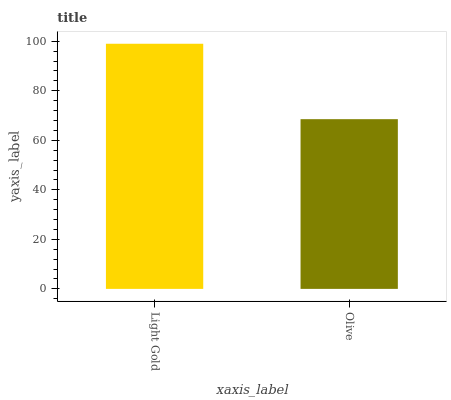Is Olive the minimum?
Answer yes or no. Yes. Is Light Gold the maximum?
Answer yes or no. Yes. Is Olive the maximum?
Answer yes or no. No. Is Light Gold greater than Olive?
Answer yes or no. Yes. Is Olive less than Light Gold?
Answer yes or no. Yes. Is Olive greater than Light Gold?
Answer yes or no. No. Is Light Gold less than Olive?
Answer yes or no. No. Is Light Gold the high median?
Answer yes or no. Yes. Is Olive the low median?
Answer yes or no. Yes. Is Olive the high median?
Answer yes or no. No. Is Light Gold the low median?
Answer yes or no. No. 